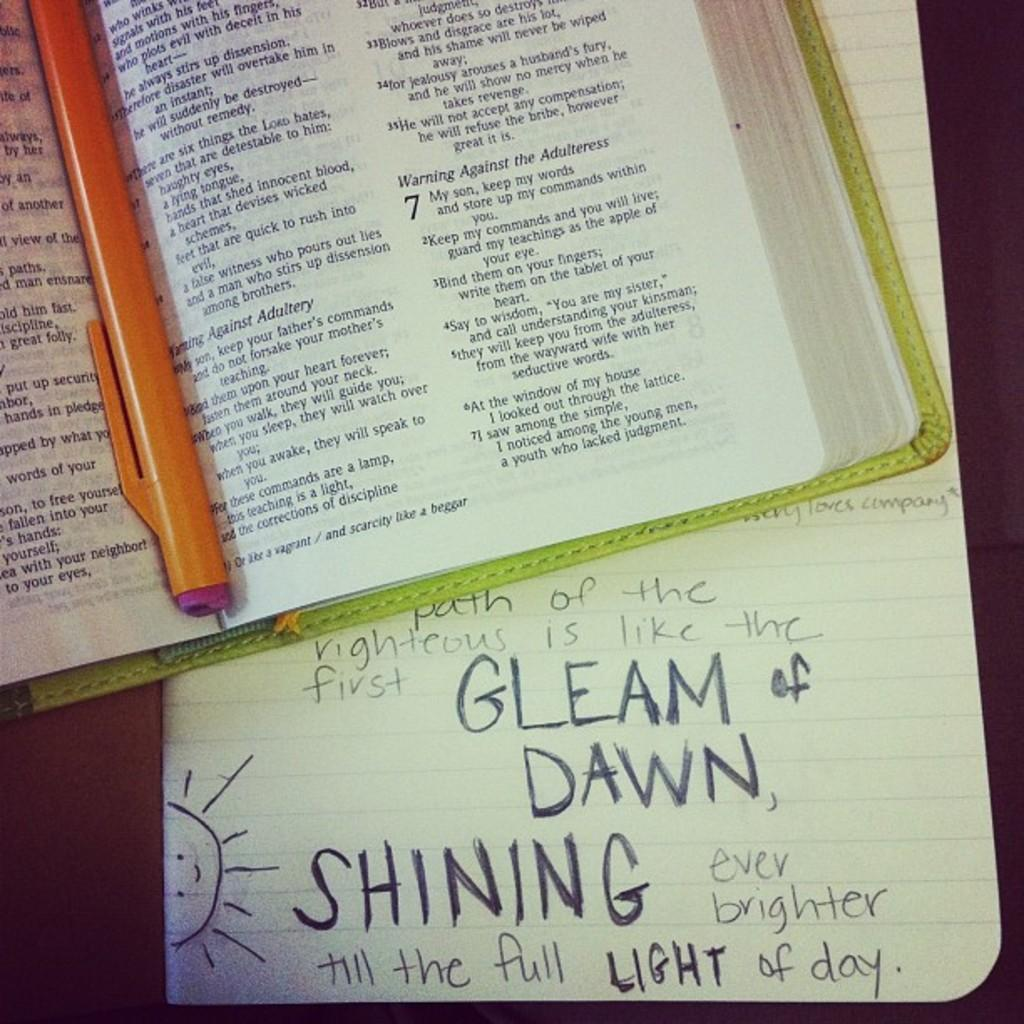<image>
Create a compact narrative representing the image presented. A bible with a pencil along the spine lays open, and a sheet of paper with handwritten notes highlighting the path of the righteous is below it. 